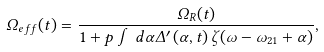<formula> <loc_0><loc_0><loc_500><loc_500>\Omega _ { e f f } ( t ) = \frac { \Omega _ { R } ( t ) } { 1 + p \int d \alpha \Delta ^ { \prime } \left ( \alpha , t \right ) \zeta ( \omega - \omega _ { 2 1 } + \alpha ) } ,</formula> 